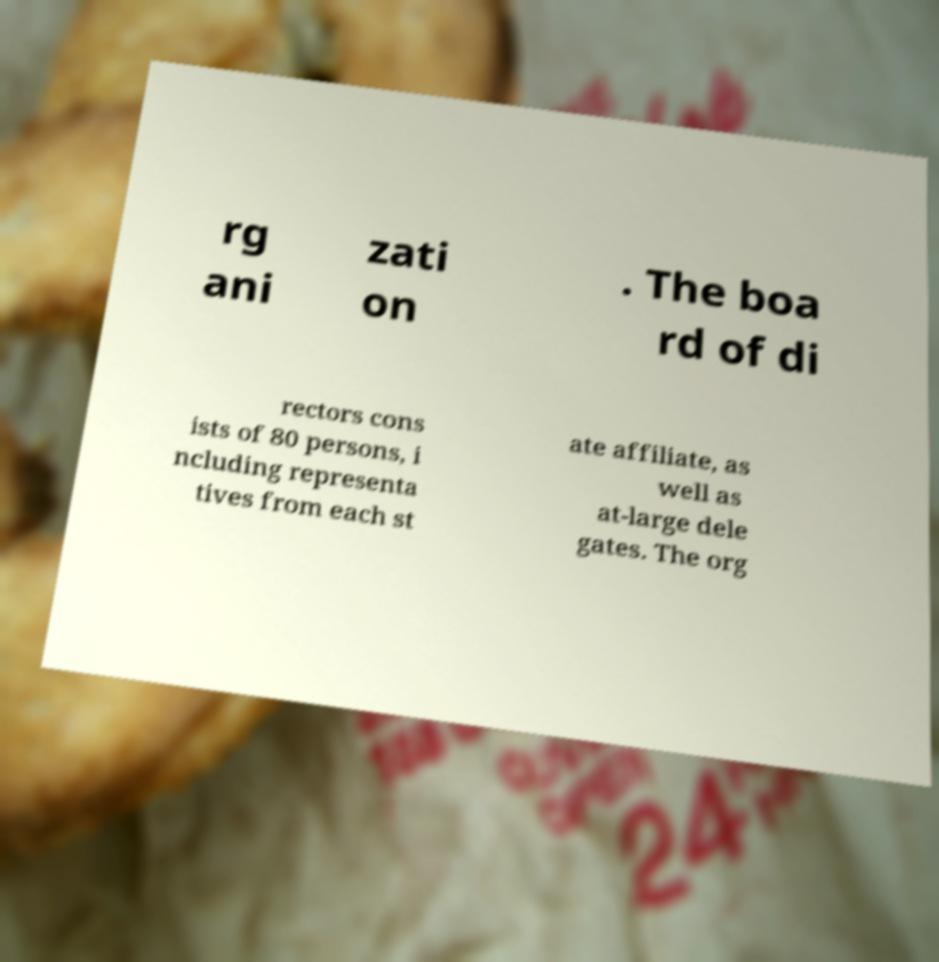I need the written content from this picture converted into text. Can you do that? rg ani zati on . The boa rd of di rectors cons ists of 80 persons, i ncluding representa tives from each st ate affiliate, as well as at-large dele gates. The org 